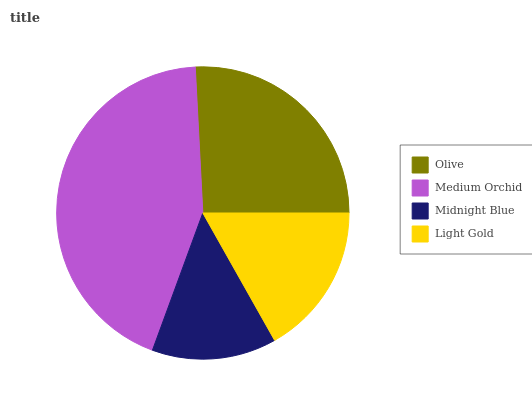Is Midnight Blue the minimum?
Answer yes or no. Yes. Is Medium Orchid the maximum?
Answer yes or no. Yes. Is Medium Orchid the minimum?
Answer yes or no. No. Is Midnight Blue the maximum?
Answer yes or no. No. Is Medium Orchid greater than Midnight Blue?
Answer yes or no. Yes. Is Midnight Blue less than Medium Orchid?
Answer yes or no. Yes. Is Midnight Blue greater than Medium Orchid?
Answer yes or no. No. Is Medium Orchid less than Midnight Blue?
Answer yes or no. No. Is Olive the high median?
Answer yes or no. Yes. Is Light Gold the low median?
Answer yes or no. Yes. Is Medium Orchid the high median?
Answer yes or no. No. Is Medium Orchid the low median?
Answer yes or no. No. 